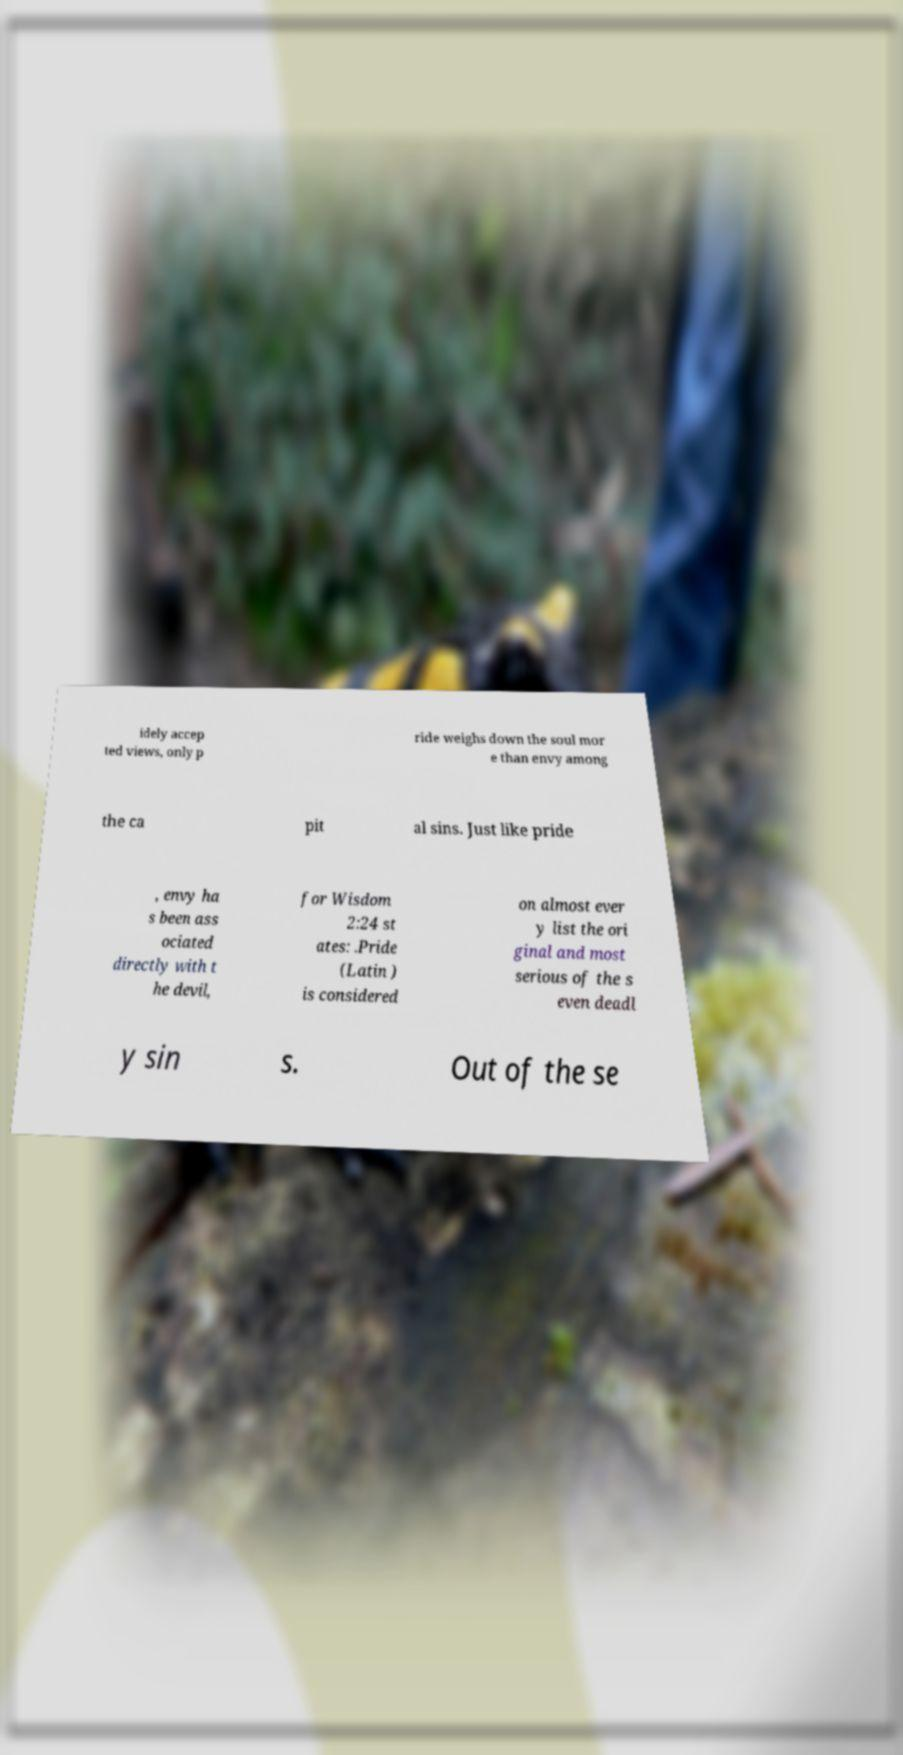Please identify and transcribe the text found in this image. idely accep ted views, only p ride weighs down the soul mor e than envy among the ca pit al sins. Just like pride , envy ha s been ass ociated directly with t he devil, for Wisdom 2:24 st ates: .Pride (Latin ) is considered on almost ever y list the ori ginal and most serious of the s even deadl y sin s. Out of the se 